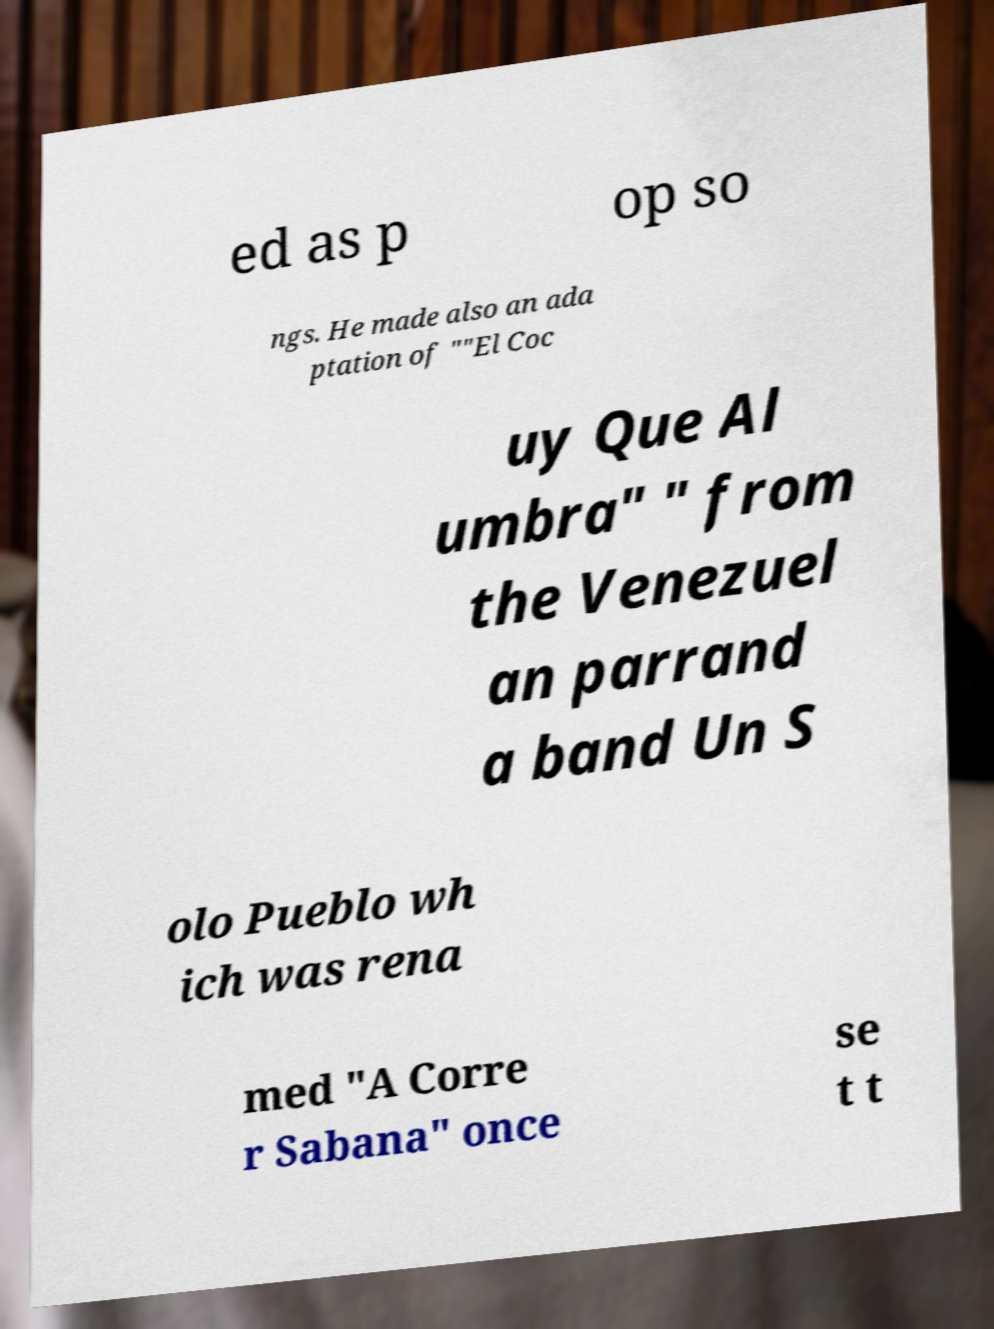Could you assist in decoding the text presented in this image and type it out clearly? ed as p op so ngs. He made also an ada ptation of ""El Coc uy Que Al umbra" " from the Venezuel an parrand a band Un S olo Pueblo wh ich was rena med "A Corre r Sabana" once se t t 